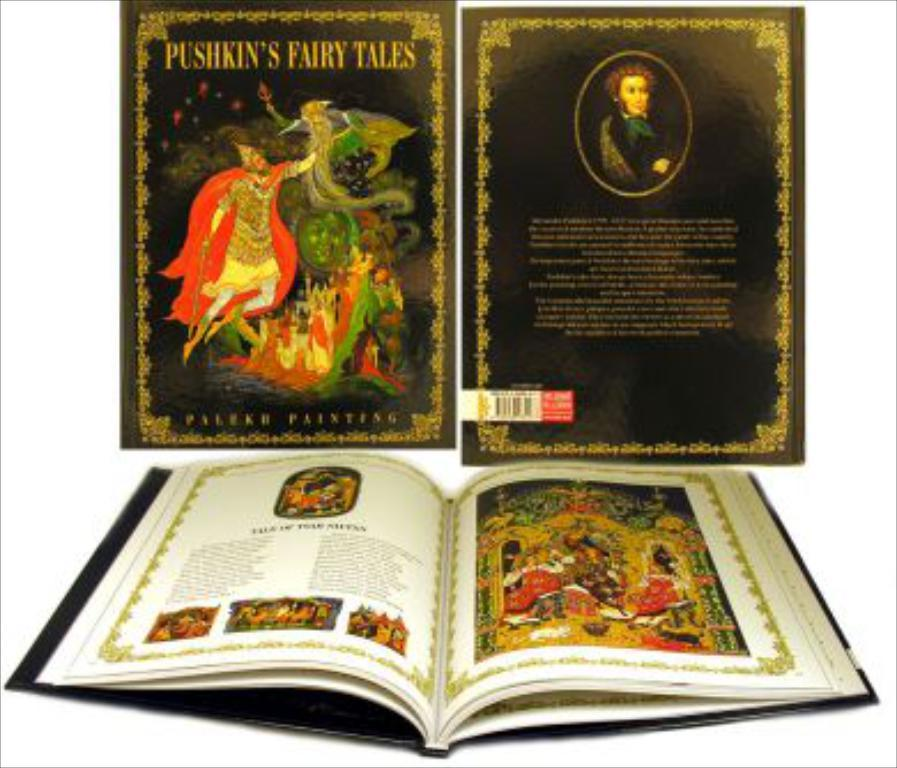What object is present in the image? There is a book in the image. What are the book covers made of? The book covers have words and pictures of people. What is the color of the background in the image? The background of the image is white. What type of plant is growing on the book cover? There is no plant growing on the book cover; it has words and pictures of people. What nation is represented by the people on the book cover? The book cover does not represent any specific nation; it simply has pictures pictures of people. 